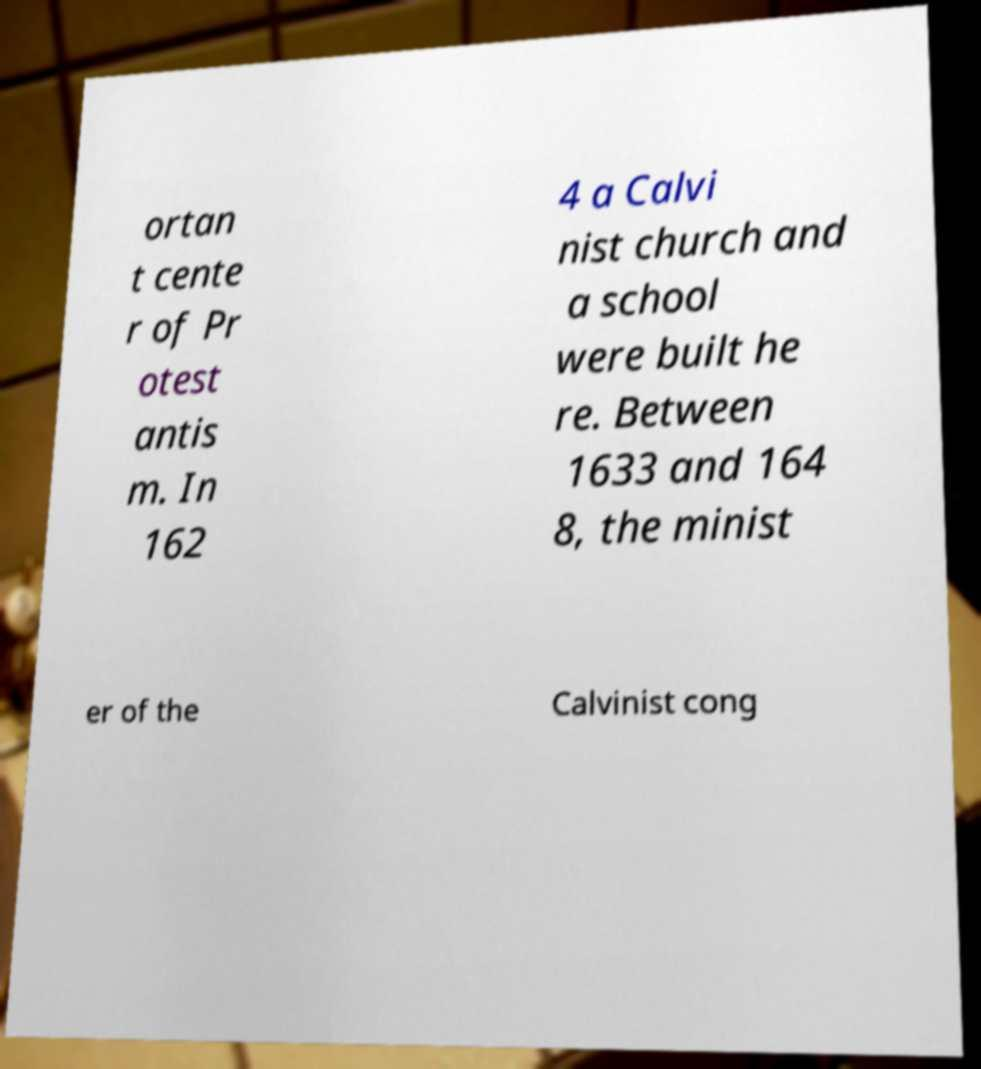Could you assist in decoding the text presented in this image and type it out clearly? ortan t cente r of Pr otest antis m. In 162 4 a Calvi nist church and a school were built he re. Between 1633 and 164 8, the minist er of the Calvinist cong 